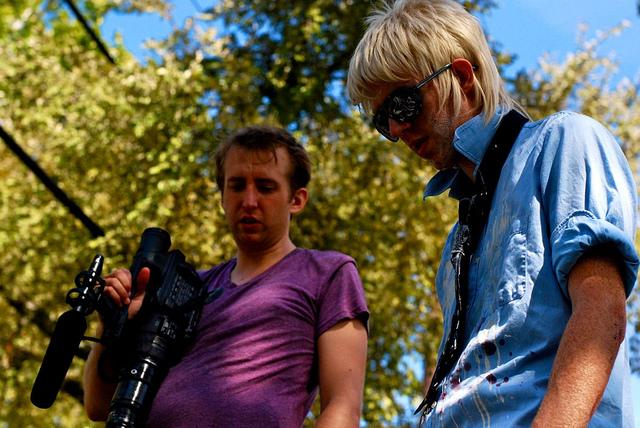Why is this man holding a camera?
Quick response, please. Yes. What is on the left side of the photo?
Short answer required. Camera. Is the man taking on the phone?
Write a very short answer. No. Are both people male?
Short answer required. Yes. What color is the camera man's shirt?
Quick response, please. Purple. 